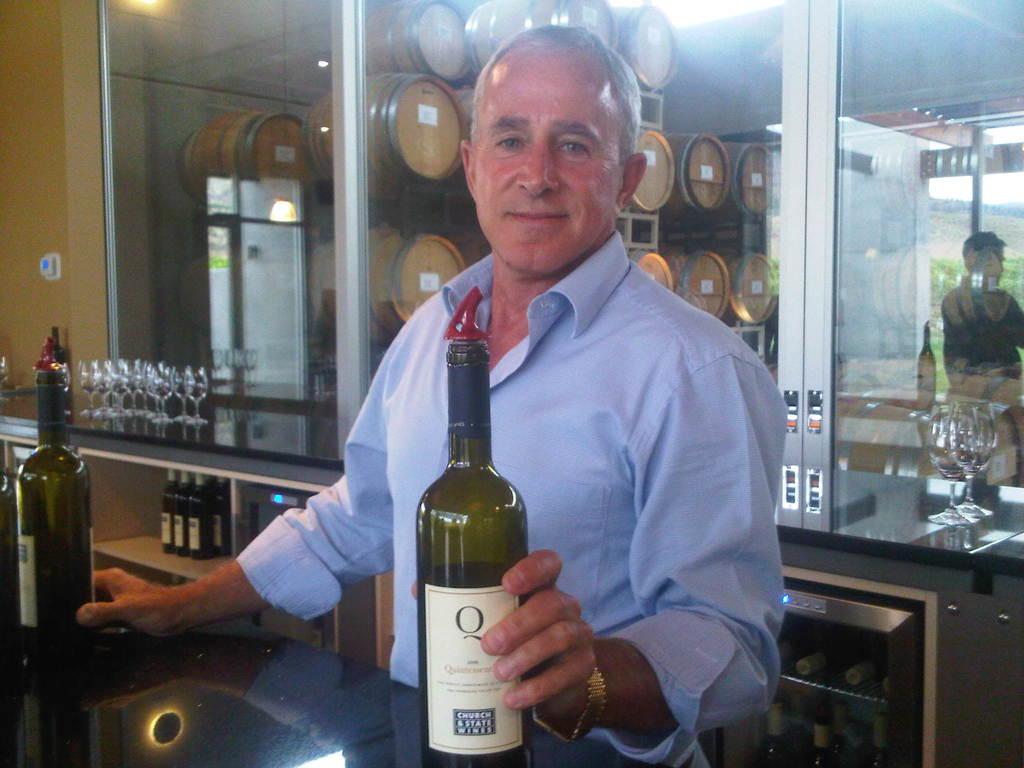What letter is on the bottle?
Keep it short and to the point. Q. 